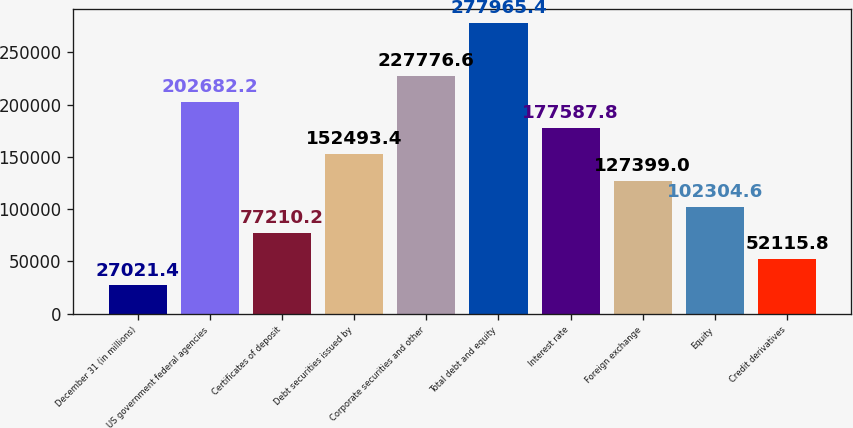<chart> <loc_0><loc_0><loc_500><loc_500><bar_chart><fcel>December 31 (in millions)<fcel>US government federal agencies<fcel>Certificates of deposit<fcel>Debt securities issued by<fcel>Corporate securities and other<fcel>Total debt and equity<fcel>Interest rate<fcel>Foreign exchange<fcel>Equity<fcel>Credit derivatives<nl><fcel>27021.4<fcel>202682<fcel>77210.2<fcel>152493<fcel>227777<fcel>277965<fcel>177588<fcel>127399<fcel>102305<fcel>52115.8<nl></chart> 